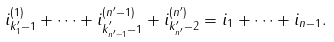<formula> <loc_0><loc_0><loc_500><loc_500>i _ { { k ^ { \prime } _ { 1 } } - 1 } ^ { ( 1 ) } + \cdots + i _ { { k ^ { ^ { \prime } } _ { n ^ { \prime } - 1 } } - 1 } ^ { ( n ^ { \prime } - 1 ) } + i _ { { k ^ { \prime } _ { n ^ { \prime } } - 2 } } ^ { ( n ^ { \prime } ) } = i _ { 1 } + \cdots + i _ { n - 1 } .</formula> 